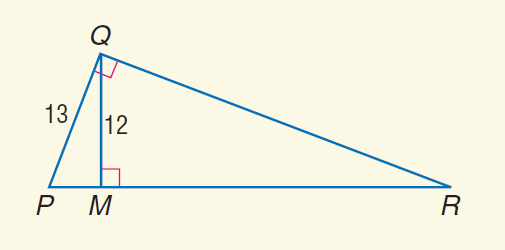Question: Find the perimeter of \triangle P Q R, if \triangle P Q M \sim \triangle P R Q.
Choices:
A. 30
B. 65
C. 78
D. 81
Answer with the letter. Answer: C 